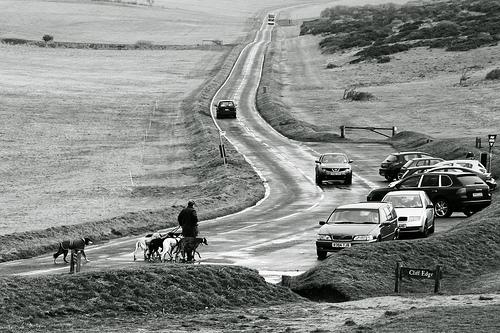Briefly describe the scene depicted in the image. The scene shows a man walking his dogs on leashes, various cars parked or driving on the road, a sign on two posts, a field of trimmed grass, and a gate between two hills. Answer a "why" question about the image based on the objects and their positions. Possibly, it's a popular area for leisure drives or a parking spot close to a nearby attraction or trail. What kind of activity is visible in the image and where is it taking place? People are walking their dogs, cars are parked or driving, and there is a sign on the side of the road, all occurring in a grassy area with some hills. In a sentence, describe any objects in the image that contribute to the overall scene's atmosphere. The sign on two posts, the grassy hills, and the trimmed grass field contribute to the image's serene, rural atmosphere. Explain the interactions between the objects or subjects in the image. The man is walking his dogs, who are interacting with each other and following the man. Cars are either parked alongside the road, close to the man and dogs, or are driving on the tarmac. How many animals can be spotted in the picture, and what are their species? Several dogs can be seen in the image, some walking with the man while others are alone or in a group. Count the number of cars mentioned in the image and classify them based on their position. There are a total of nine cars - four parked, four driving, and one bus driving. What emotions or sentiments do you think the image conveys? The image conveys a peaceful outdoor scene with a sense of relaxation and leisurely activities such as walking dogs and driving along the scenic route. Enumerate the objects or subjects that can be found in the image. Man, dogs, car, parked car, driving car, road, hill, grass, sign, gate, trees, farmlands, scrub brush, vest, leashes, posts, tarmac, and bus. Rate the quality of the image out of 10, considering factors like clarity, composition, and focus. 7 out of 10, as the image is relatively clear but has room for improvement in terms of focus and composition. Is there a woman walking with the man who is walking the dogs? No, it's not mentioned in the image. 